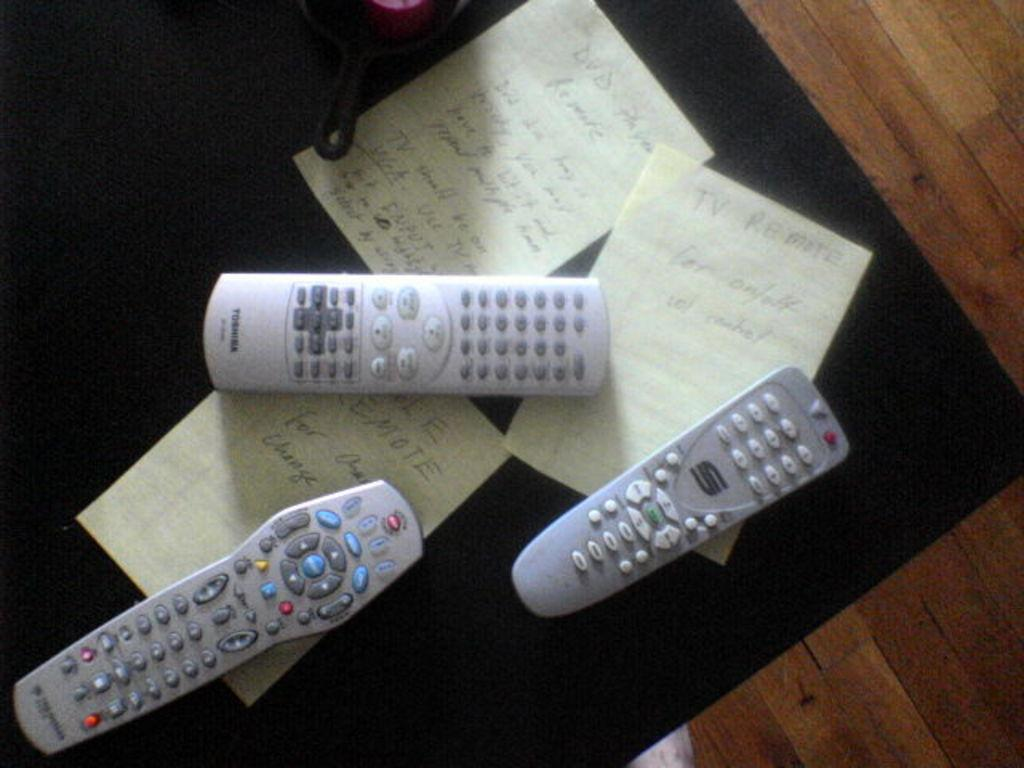<image>
Provide a brief description of the given image. Three television remote controls with the one in the middle having the toshiba logo on it. 